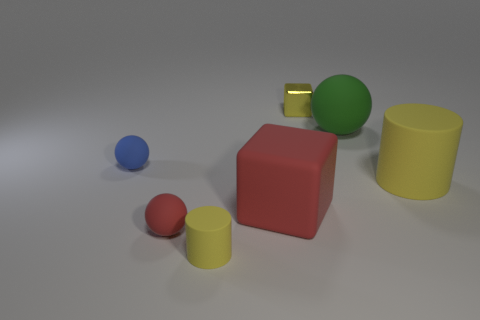Subtract all red cubes. Subtract all green cylinders. How many cubes are left? 1 Add 2 red rubber spheres. How many objects exist? 9 Subtract all blocks. How many objects are left? 5 Add 2 big cylinders. How many big cylinders are left? 3 Add 6 matte spheres. How many matte spheres exist? 9 Subtract 1 red cubes. How many objects are left? 6 Subtract all cylinders. Subtract all blue rubber balls. How many objects are left? 4 